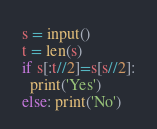<code> <loc_0><loc_0><loc_500><loc_500><_Python_>s = input()
t = len(s)
if s[:t//2]=s[s//2]:
  print('Yes')
else: print('No')</code> 